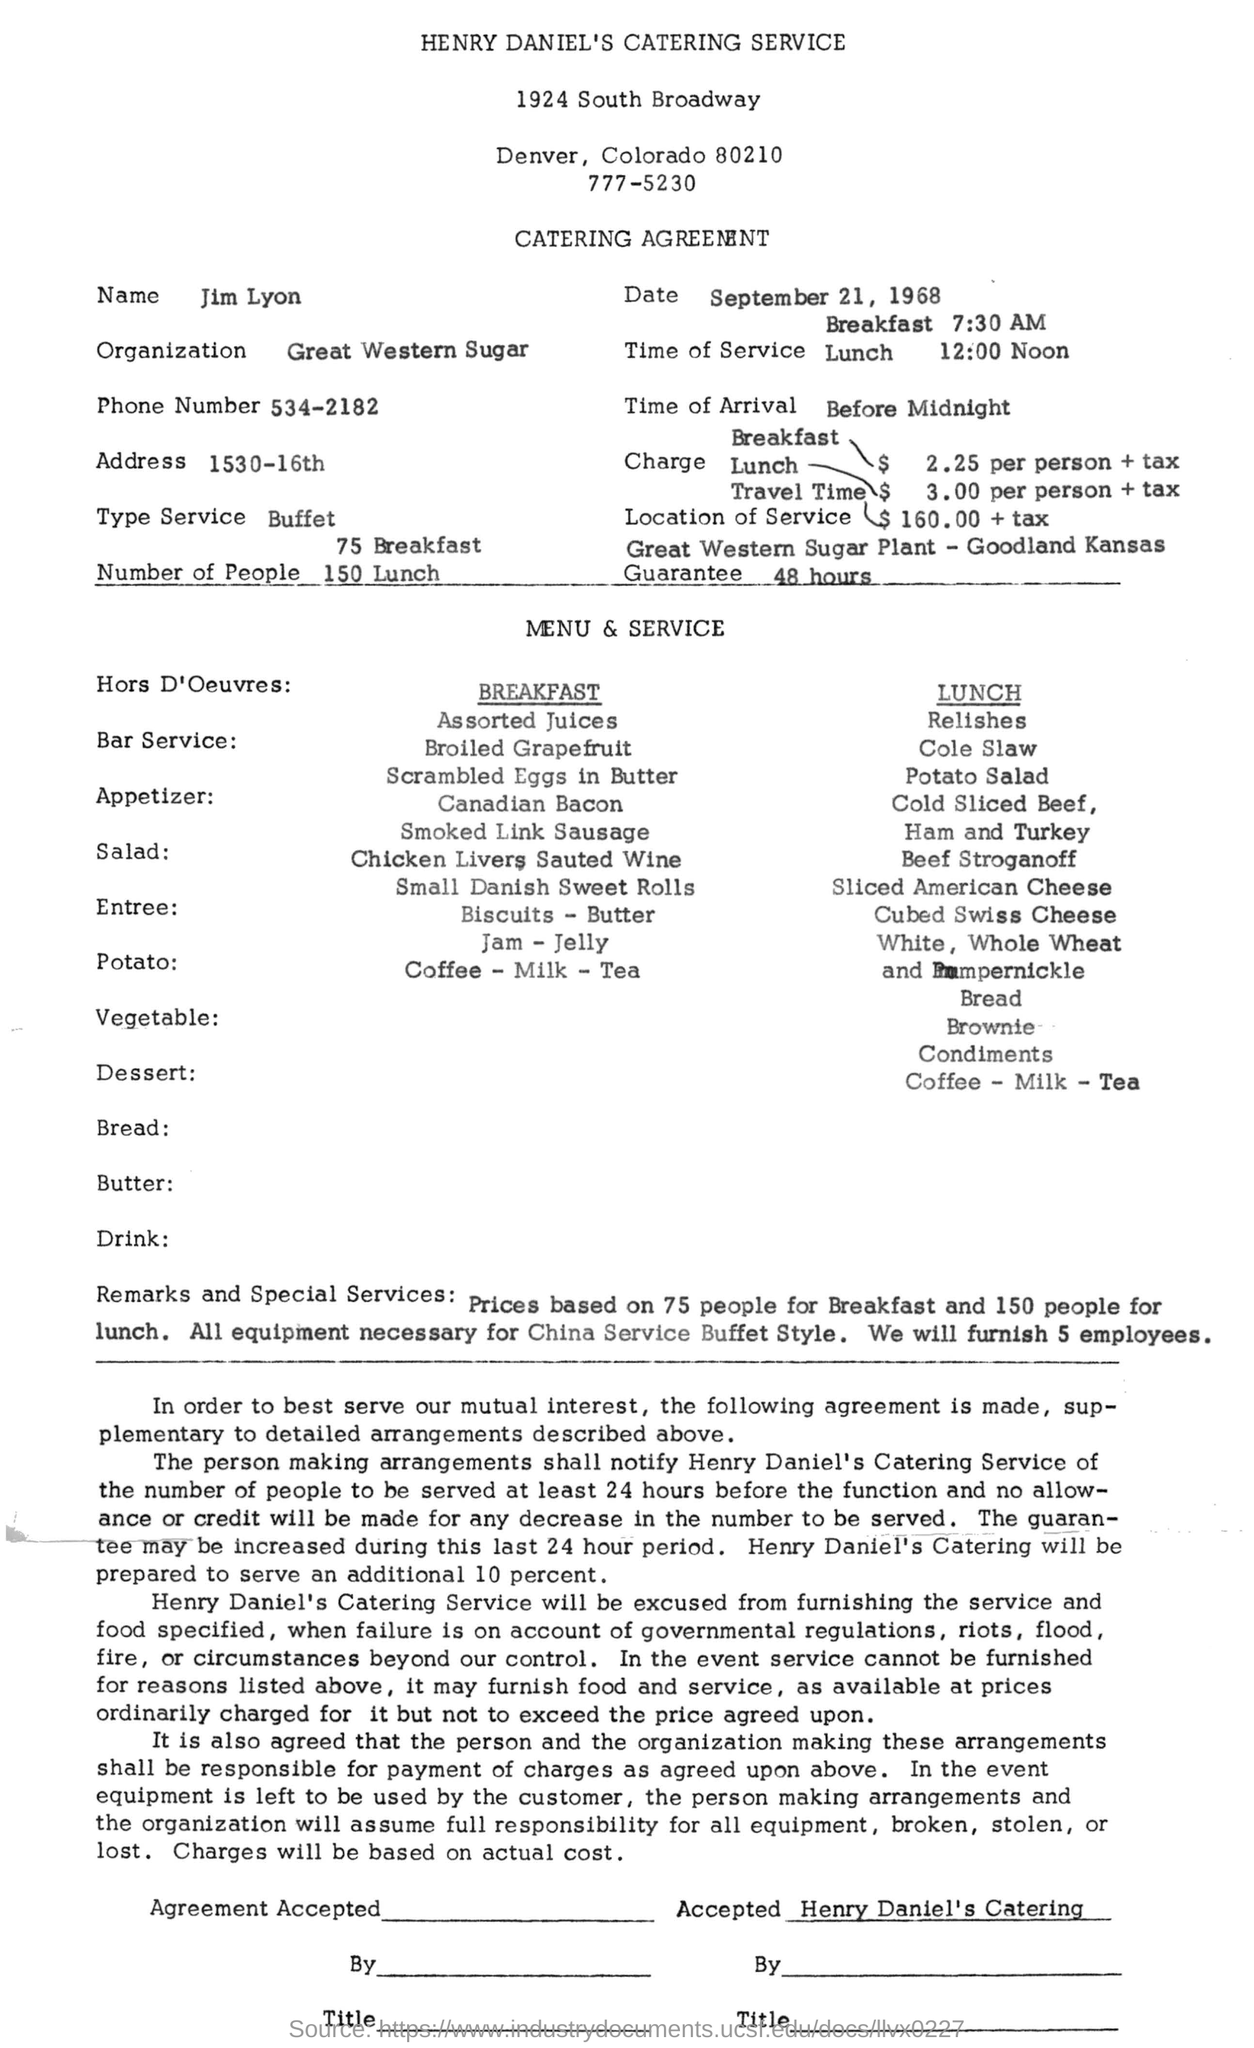Mention a couple of crucial points in this snapshot. The type of service is a buffet. The date mentioned in the document is September 21, 1968. This is a catering agreement. The catering agreement states that the person's name is Jim Lyon. Great Western Sugar is the name of the organization. 